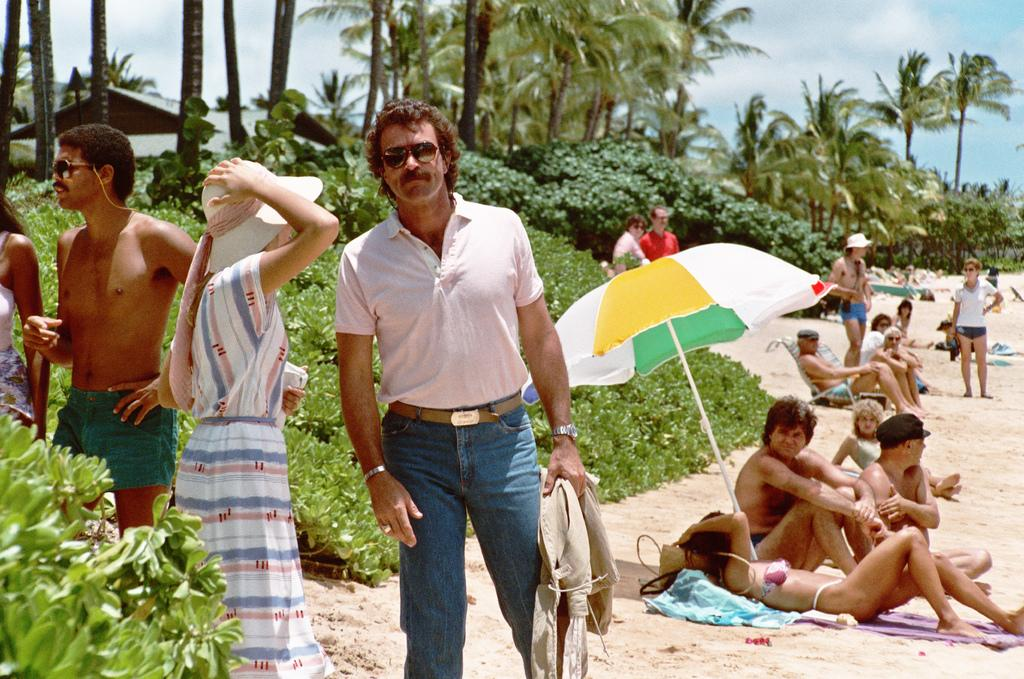What are the people in the image doing? There are people standing in front of the image, and others are lying on the sand behind them. What can be seen in the background of the image? There are trees visible in the background. What type of bead is being used to decorate the cars in the image? There are no cars present in the image, so there is no bead decoration to discuss. 